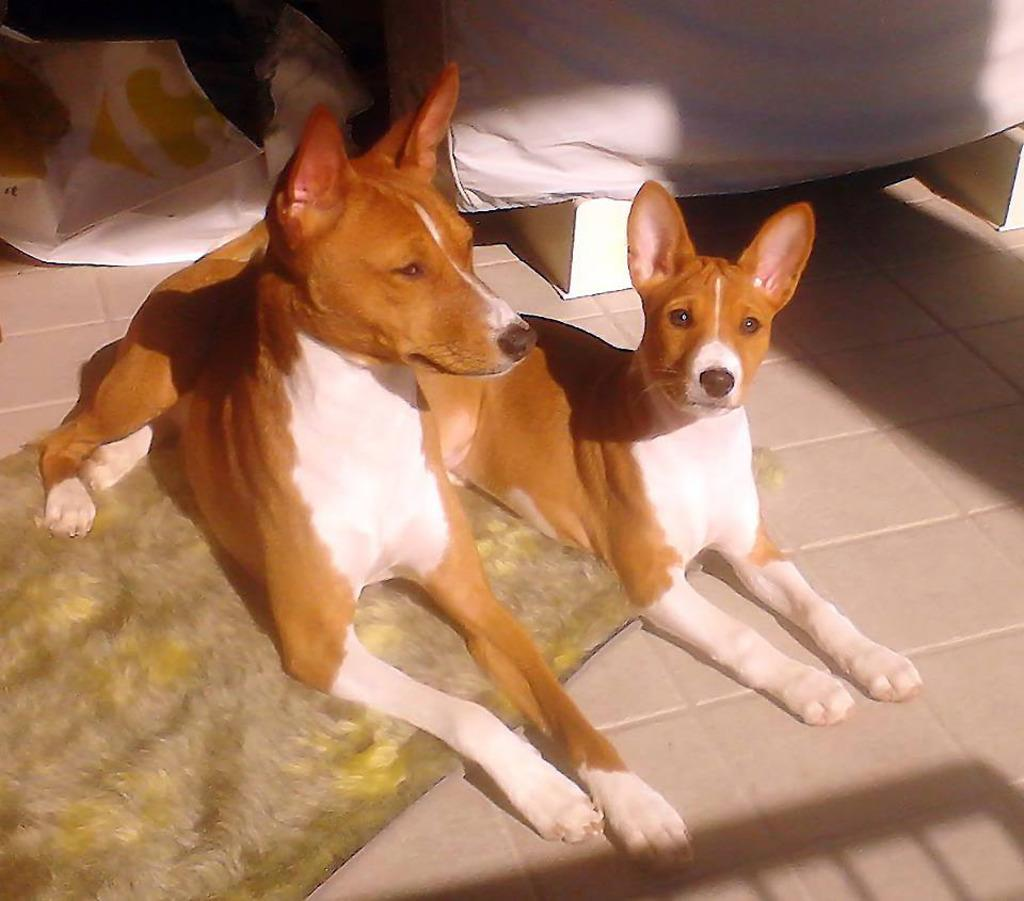How many dogs are present in the image? There are two dogs in the image. What are the positions of the dogs in the image? One dog is sitting on a mat, and the other dog is sitting on the floor. What can be seen in the background of the image? There is a white color cloth in the background of the image. What type of jewel is the dog wearing around its neck in the image? There is no dog wearing a jewel around its neck in the image; both dogs are simply sitting on a mat and the floor. 